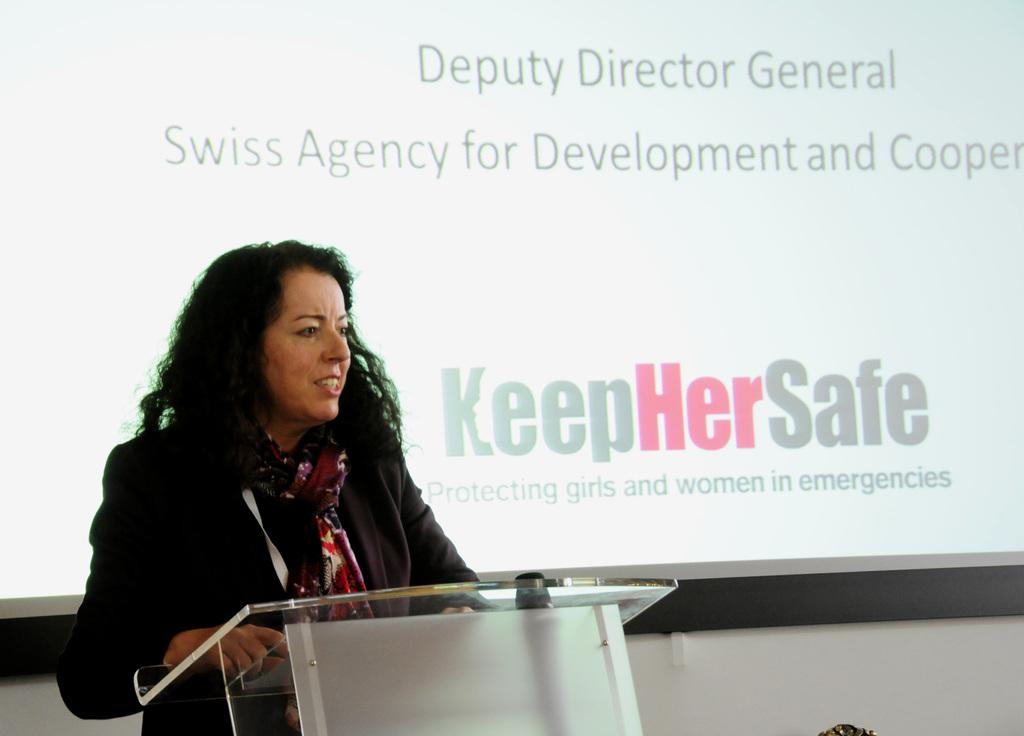What is the woman wearing around her neck in the image? The woman is wearing a scarf in the image. What expression does the woman have on her face? The woman is smiling in the image. What object is in front of the woman? There is a podium in front of the woman. What is visible behind the woman? There is a screen behind the woman. What is the name of the wind that can be seen blowing in the image? There is no wind present in the image, so it is not possible to determine the name of any wind. 